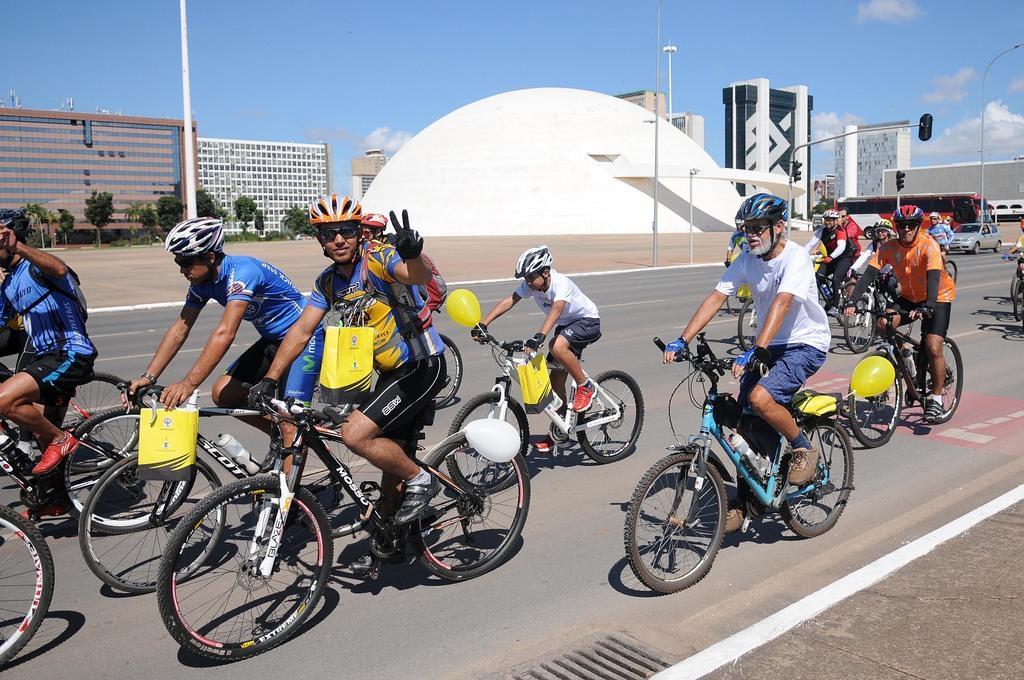Could you give a brief overview of what you see in this image? In this image few people are riding the bicycles on the road. Right side there is a bicycle having a balloon. A person is riding the bicycle. He is wearing a helmet. People are wearing helmets. Right side there are traffic lights attached to the poles. Few vehicles are on the road. Few poles are on the pavement. Left side there are trees. Background there are buildings. Top of the image there is sky with some clouds. 